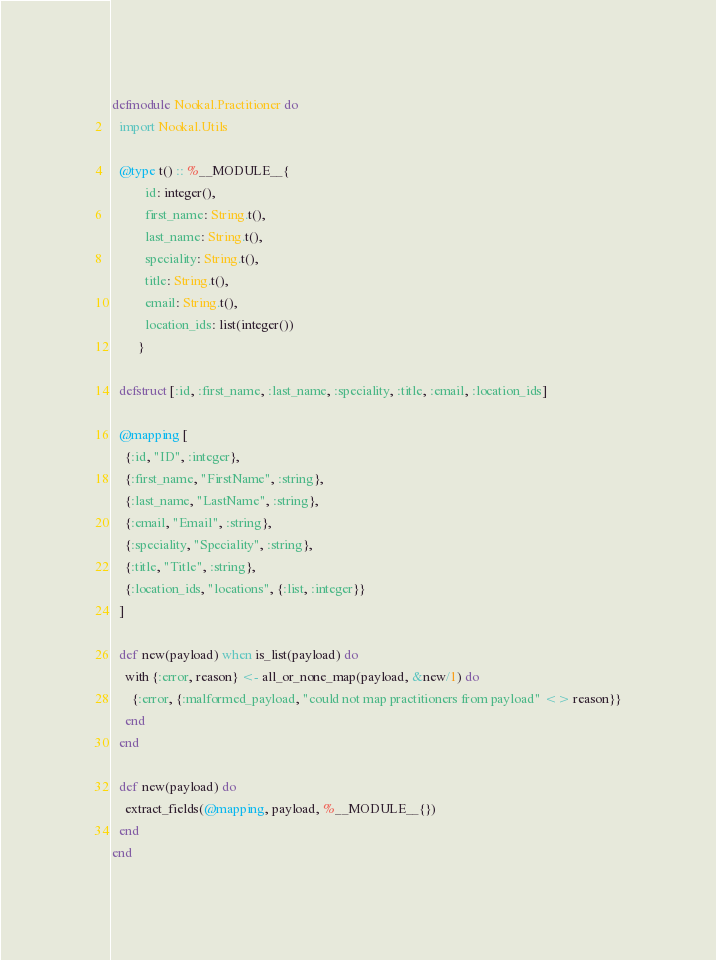<code> <loc_0><loc_0><loc_500><loc_500><_Elixir_>defmodule Nookal.Practitioner do
  import Nookal.Utils

  @type t() :: %__MODULE__{
          id: integer(),
          first_name: String.t(),
          last_name: String.t(),
          speciality: String.t(),
          title: String.t(),
          email: String.t(),
          location_ids: list(integer())
        }

  defstruct [:id, :first_name, :last_name, :speciality, :title, :email, :location_ids]

  @mapping [
    {:id, "ID", :integer},
    {:first_name, "FirstName", :string},
    {:last_name, "LastName", :string},
    {:email, "Email", :string},
    {:speciality, "Speciality", :string},
    {:title, "Title", :string},
    {:location_ids, "locations", {:list, :integer}}
  ]

  def new(payload) when is_list(payload) do
    with {:error, reason} <- all_or_none_map(payload, &new/1) do
      {:error, {:malformed_payload, "could not map practitioners from payload" <> reason}}
    end
  end

  def new(payload) do
    extract_fields(@mapping, payload, %__MODULE__{})
  end
end
</code> 